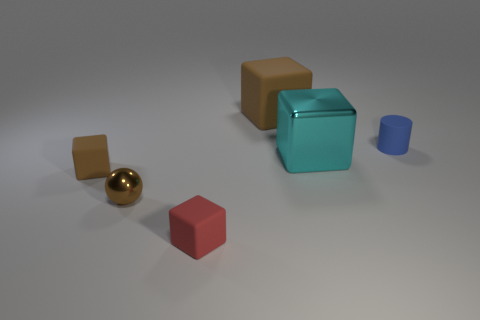How big is the blue object?
Make the answer very short. Small. How many other things are there of the same size as the metallic ball?
Provide a short and direct response. 3. What is the size of the metal object in front of the small block behind the tiny red thing?
Keep it short and to the point. Small. How many tiny things are either metal objects or red things?
Make the answer very short. 2. How big is the brown matte object that is to the right of the tiny matte block that is to the left of the tiny cube in front of the small brown metal sphere?
Keep it short and to the point. Large. Are there any other things of the same color as the large shiny object?
Provide a succinct answer. No. What is the material of the tiny brown thing in front of the small matte cube left of the shiny object that is to the left of the large brown matte object?
Your answer should be very brief. Metal. Is the shape of the large cyan metal object the same as the red matte thing?
Provide a short and direct response. Yes. What number of metallic things are both behind the tiny brown shiny sphere and left of the red matte thing?
Your answer should be very brief. 0. There is a rubber cylinder right of the big cube that is behind the rubber cylinder; what is its color?
Offer a very short reply. Blue. 